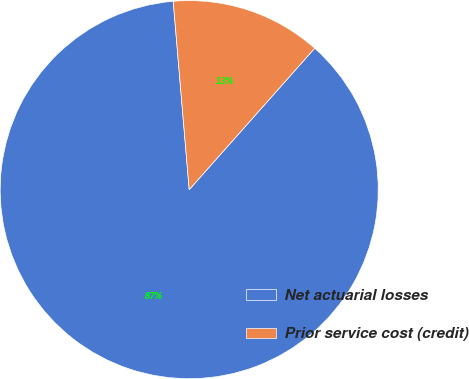Convert chart. <chart><loc_0><loc_0><loc_500><loc_500><pie_chart><fcel>Net actuarial losses<fcel>Prior service cost (credit)<nl><fcel>87.1%<fcel>12.9%<nl></chart> 